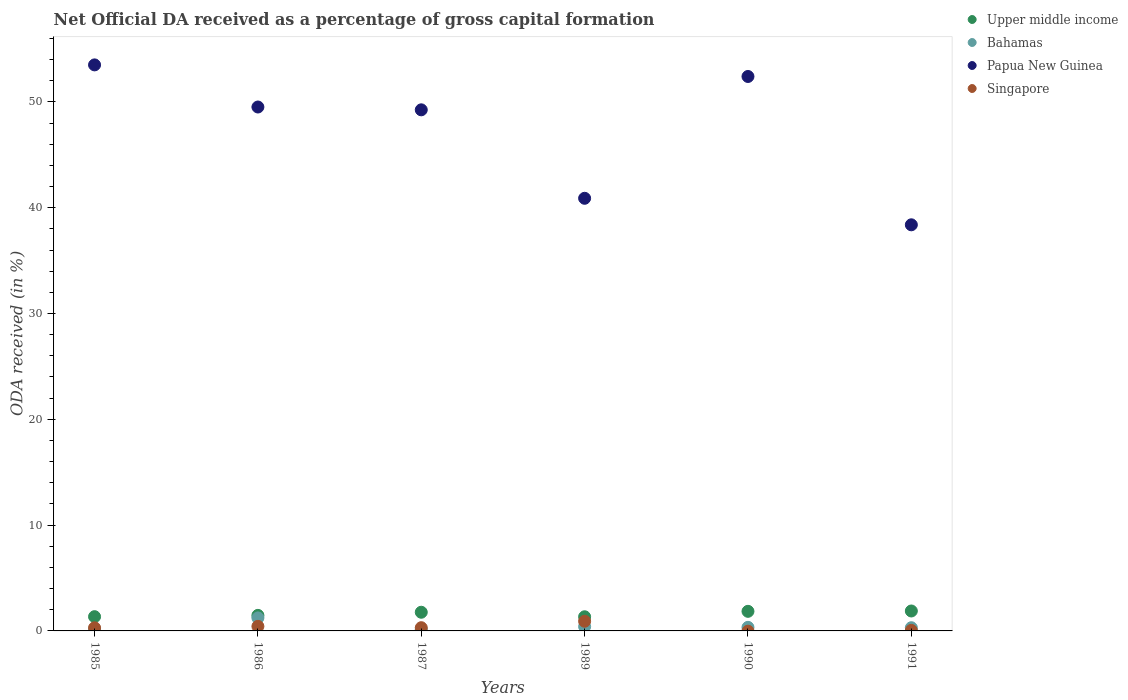Is the number of dotlines equal to the number of legend labels?
Provide a short and direct response. No. What is the net ODA received in Papua New Guinea in 1989?
Ensure brevity in your answer.  40.89. Across all years, what is the maximum net ODA received in Upper middle income?
Provide a short and direct response. 1.88. Across all years, what is the minimum net ODA received in Bahamas?
Your answer should be very brief. 0.13. What is the total net ODA received in Bahamas in the graph?
Offer a very short reply. 2.56. What is the difference between the net ODA received in Bahamas in 1985 and that in 1991?
Offer a terse response. -0.14. What is the difference between the net ODA received in Bahamas in 1989 and the net ODA received in Upper middle income in 1986?
Your answer should be compact. -1.06. What is the average net ODA received in Papua New Guinea per year?
Provide a short and direct response. 47.32. In the year 1991, what is the difference between the net ODA received in Singapore and net ODA received in Bahamas?
Keep it short and to the point. -0.25. In how many years, is the net ODA received in Papua New Guinea greater than 32 %?
Your answer should be compact. 6. What is the ratio of the net ODA received in Singapore in 1986 to that in 1989?
Give a very brief answer. 0.47. Is the net ODA received in Upper middle income in 1989 less than that in 1991?
Your answer should be compact. Yes. Is the difference between the net ODA received in Singapore in 1986 and 1987 greater than the difference between the net ODA received in Bahamas in 1986 and 1987?
Your answer should be very brief. No. What is the difference between the highest and the second highest net ODA received in Papua New Guinea?
Keep it short and to the point. 1.1. What is the difference between the highest and the lowest net ODA received in Singapore?
Provide a short and direct response. 0.91. Is it the case that in every year, the sum of the net ODA received in Bahamas and net ODA received in Singapore  is greater than the net ODA received in Upper middle income?
Make the answer very short. No. How many years are there in the graph?
Offer a very short reply. 6. Are the values on the major ticks of Y-axis written in scientific E-notation?
Provide a short and direct response. No. How are the legend labels stacked?
Your response must be concise. Vertical. What is the title of the graph?
Your answer should be compact. Net Official DA received as a percentage of gross capital formation. Does "Lesotho" appear as one of the legend labels in the graph?
Offer a terse response. No. What is the label or title of the Y-axis?
Keep it short and to the point. ODA received (in %). What is the ODA received (in %) in Upper middle income in 1985?
Give a very brief answer. 1.35. What is the ODA received (in %) in Bahamas in 1985?
Ensure brevity in your answer.  0.16. What is the ODA received (in %) of Papua New Guinea in 1985?
Make the answer very short. 53.5. What is the ODA received (in %) in Singapore in 1985?
Provide a succinct answer. 0.3. What is the ODA received (in %) of Upper middle income in 1986?
Provide a short and direct response. 1.47. What is the ODA received (in %) in Bahamas in 1986?
Make the answer very short. 1.23. What is the ODA received (in %) of Papua New Guinea in 1986?
Offer a terse response. 49.52. What is the ODA received (in %) of Singapore in 1986?
Provide a short and direct response. 0.43. What is the ODA received (in %) of Upper middle income in 1987?
Your answer should be compact. 1.76. What is the ODA received (in %) of Bahamas in 1987?
Keep it short and to the point. 0.13. What is the ODA received (in %) of Papua New Guinea in 1987?
Provide a succinct answer. 49.25. What is the ODA received (in %) in Singapore in 1987?
Keep it short and to the point. 0.3. What is the ODA received (in %) in Upper middle income in 1989?
Provide a succinct answer. 1.34. What is the ODA received (in %) in Bahamas in 1989?
Your answer should be compact. 0.41. What is the ODA received (in %) of Papua New Guinea in 1989?
Your answer should be very brief. 40.89. What is the ODA received (in %) of Singapore in 1989?
Your response must be concise. 0.91. What is the ODA received (in %) of Upper middle income in 1990?
Your response must be concise. 1.85. What is the ODA received (in %) of Bahamas in 1990?
Offer a terse response. 0.34. What is the ODA received (in %) of Papua New Guinea in 1990?
Your answer should be compact. 52.4. What is the ODA received (in %) in Upper middle income in 1991?
Offer a terse response. 1.88. What is the ODA received (in %) in Bahamas in 1991?
Your answer should be very brief. 0.3. What is the ODA received (in %) of Papua New Guinea in 1991?
Offer a very short reply. 38.38. What is the ODA received (in %) in Singapore in 1991?
Offer a very short reply. 0.05. Across all years, what is the maximum ODA received (in %) of Upper middle income?
Provide a succinct answer. 1.88. Across all years, what is the maximum ODA received (in %) in Bahamas?
Offer a terse response. 1.23. Across all years, what is the maximum ODA received (in %) of Papua New Guinea?
Make the answer very short. 53.5. Across all years, what is the maximum ODA received (in %) of Singapore?
Provide a succinct answer. 0.91. Across all years, what is the minimum ODA received (in %) of Upper middle income?
Ensure brevity in your answer.  1.34. Across all years, what is the minimum ODA received (in %) in Bahamas?
Offer a very short reply. 0.13. Across all years, what is the minimum ODA received (in %) of Papua New Guinea?
Provide a short and direct response. 38.38. What is the total ODA received (in %) of Upper middle income in the graph?
Your answer should be very brief. 9.65. What is the total ODA received (in %) of Bahamas in the graph?
Make the answer very short. 2.56. What is the total ODA received (in %) in Papua New Guinea in the graph?
Ensure brevity in your answer.  283.94. What is the total ODA received (in %) of Singapore in the graph?
Your answer should be very brief. 2. What is the difference between the ODA received (in %) in Upper middle income in 1985 and that in 1986?
Offer a very short reply. -0.12. What is the difference between the ODA received (in %) in Bahamas in 1985 and that in 1986?
Provide a succinct answer. -1.07. What is the difference between the ODA received (in %) of Papua New Guinea in 1985 and that in 1986?
Give a very brief answer. 3.98. What is the difference between the ODA received (in %) of Singapore in 1985 and that in 1986?
Provide a succinct answer. -0.14. What is the difference between the ODA received (in %) of Upper middle income in 1985 and that in 1987?
Your answer should be compact. -0.42. What is the difference between the ODA received (in %) in Bahamas in 1985 and that in 1987?
Offer a terse response. 0.03. What is the difference between the ODA received (in %) in Papua New Guinea in 1985 and that in 1987?
Give a very brief answer. 4.25. What is the difference between the ODA received (in %) of Singapore in 1985 and that in 1987?
Your answer should be compact. -0.01. What is the difference between the ODA received (in %) of Upper middle income in 1985 and that in 1989?
Provide a succinct answer. 0.01. What is the difference between the ODA received (in %) of Bahamas in 1985 and that in 1989?
Your response must be concise. -0.25. What is the difference between the ODA received (in %) in Papua New Guinea in 1985 and that in 1989?
Provide a short and direct response. 12.61. What is the difference between the ODA received (in %) in Singapore in 1985 and that in 1989?
Your answer should be very brief. -0.62. What is the difference between the ODA received (in %) of Upper middle income in 1985 and that in 1990?
Your response must be concise. -0.5. What is the difference between the ODA received (in %) of Bahamas in 1985 and that in 1990?
Make the answer very short. -0.18. What is the difference between the ODA received (in %) in Papua New Guinea in 1985 and that in 1990?
Your answer should be very brief. 1.1. What is the difference between the ODA received (in %) in Upper middle income in 1985 and that in 1991?
Give a very brief answer. -0.54. What is the difference between the ODA received (in %) in Bahamas in 1985 and that in 1991?
Keep it short and to the point. -0.14. What is the difference between the ODA received (in %) of Papua New Guinea in 1985 and that in 1991?
Your answer should be very brief. 15.11. What is the difference between the ODA received (in %) in Singapore in 1985 and that in 1991?
Your answer should be compact. 0.24. What is the difference between the ODA received (in %) in Upper middle income in 1986 and that in 1987?
Make the answer very short. -0.3. What is the difference between the ODA received (in %) in Bahamas in 1986 and that in 1987?
Make the answer very short. 1.1. What is the difference between the ODA received (in %) in Papua New Guinea in 1986 and that in 1987?
Make the answer very short. 0.27. What is the difference between the ODA received (in %) in Singapore in 1986 and that in 1987?
Provide a short and direct response. 0.13. What is the difference between the ODA received (in %) in Upper middle income in 1986 and that in 1989?
Offer a very short reply. 0.13. What is the difference between the ODA received (in %) in Bahamas in 1986 and that in 1989?
Make the answer very short. 0.82. What is the difference between the ODA received (in %) of Papua New Guinea in 1986 and that in 1989?
Keep it short and to the point. 8.63. What is the difference between the ODA received (in %) in Singapore in 1986 and that in 1989?
Keep it short and to the point. -0.48. What is the difference between the ODA received (in %) of Upper middle income in 1986 and that in 1990?
Offer a very short reply. -0.38. What is the difference between the ODA received (in %) of Bahamas in 1986 and that in 1990?
Offer a very short reply. 0.89. What is the difference between the ODA received (in %) in Papua New Guinea in 1986 and that in 1990?
Give a very brief answer. -2.89. What is the difference between the ODA received (in %) of Upper middle income in 1986 and that in 1991?
Offer a very short reply. -0.41. What is the difference between the ODA received (in %) of Bahamas in 1986 and that in 1991?
Provide a short and direct response. 0.93. What is the difference between the ODA received (in %) of Papua New Guinea in 1986 and that in 1991?
Offer a terse response. 11.13. What is the difference between the ODA received (in %) of Singapore in 1986 and that in 1991?
Your answer should be compact. 0.38. What is the difference between the ODA received (in %) of Upper middle income in 1987 and that in 1989?
Offer a terse response. 0.43. What is the difference between the ODA received (in %) in Bahamas in 1987 and that in 1989?
Offer a terse response. -0.28. What is the difference between the ODA received (in %) of Papua New Guinea in 1987 and that in 1989?
Give a very brief answer. 8.36. What is the difference between the ODA received (in %) of Singapore in 1987 and that in 1989?
Ensure brevity in your answer.  -0.61. What is the difference between the ODA received (in %) of Upper middle income in 1987 and that in 1990?
Give a very brief answer. -0.09. What is the difference between the ODA received (in %) in Bahamas in 1987 and that in 1990?
Make the answer very short. -0.21. What is the difference between the ODA received (in %) of Papua New Guinea in 1987 and that in 1990?
Offer a very short reply. -3.15. What is the difference between the ODA received (in %) of Upper middle income in 1987 and that in 1991?
Your response must be concise. -0.12. What is the difference between the ODA received (in %) in Bahamas in 1987 and that in 1991?
Offer a terse response. -0.17. What is the difference between the ODA received (in %) in Papua New Guinea in 1987 and that in 1991?
Your response must be concise. 10.87. What is the difference between the ODA received (in %) of Singapore in 1987 and that in 1991?
Your answer should be very brief. 0.25. What is the difference between the ODA received (in %) in Upper middle income in 1989 and that in 1990?
Offer a very short reply. -0.51. What is the difference between the ODA received (in %) in Bahamas in 1989 and that in 1990?
Make the answer very short. 0.07. What is the difference between the ODA received (in %) of Papua New Guinea in 1989 and that in 1990?
Provide a succinct answer. -11.51. What is the difference between the ODA received (in %) in Upper middle income in 1989 and that in 1991?
Provide a short and direct response. -0.55. What is the difference between the ODA received (in %) of Bahamas in 1989 and that in 1991?
Give a very brief answer. 0.1. What is the difference between the ODA received (in %) in Papua New Guinea in 1989 and that in 1991?
Keep it short and to the point. 2.51. What is the difference between the ODA received (in %) of Singapore in 1989 and that in 1991?
Keep it short and to the point. 0.86. What is the difference between the ODA received (in %) in Upper middle income in 1990 and that in 1991?
Offer a very short reply. -0.03. What is the difference between the ODA received (in %) of Bahamas in 1990 and that in 1991?
Ensure brevity in your answer.  0.04. What is the difference between the ODA received (in %) of Papua New Guinea in 1990 and that in 1991?
Give a very brief answer. 14.02. What is the difference between the ODA received (in %) of Upper middle income in 1985 and the ODA received (in %) of Bahamas in 1986?
Provide a succinct answer. 0.12. What is the difference between the ODA received (in %) of Upper middle income in 1985 and the ODA received (in %) of Papua New Guinea in 1986?
Keep it short and to the point. -48.17. What is the difference between the ODA received (in %) of Upper middle income in 1985 and the ODA received (in %) of Singapore in 1986?
Ensure brevity in your answer.  0.92. What is the difference between the ODA received (in %) of Bahamas in 1985 and the ODA received (in %) of Papua New Guinea in 1986?
Your answer should be compact. -49.36. What is the difference between the ODA received (in %) in Bahamas in 1985 and the ODA received (in %) in Singapore in 1986?
Offer a terse response. -0.27. What is the difference between the ODA received (in %) of Papua New Guinea in 1985 and the ODA received (in %) of Singapore in 1986?
Provide a short and direct response. 53.07. What is the difference between the ODA received (in %) of Upper middle income in 1985 and the ODA received (in %) of Bahamas in 1987?
Ensure brevity in your answer.  1.22. What is the difference between the ODA received (in %) in Upper middle income in 1985 and the ODA received (in %) in Papua New Guinea in 1987?
Your answer should be very brief. -47.9. What is the difference between the ODA received (in %) in Upper middle income in 1985 and the ODA received (in %) in Singapore in 1987?
Ensure brevity in your answer.  1.04. What is the difference between the ODA received (in %) of Bahamas in 1985 and the ODA received (in %) of Papua New Guinea in 1987?
Provide a short and direct response. -49.09. What is the difference between the ODA received (in %) of Bahamas in 1985 and the ODA received (in %) of Singapore in 1987?
Make the answer very short. -0.15. What is the difference between the ODA received (in %) in Papua New Guinea in 1985 and the ODA received (in %) in Singapore in 1987?
Give a very brief answer. 53.19. What is the difference between the ODA received (in %) in Upper middle income in 1985 and the ODA received (in %) in Bahamas in 1989?
Your response must be concise. 0.94. What is the difference between the ODA received (in %) of Upper middle income in 1985 and the ODA received (in %) of Papua New Guinea in 1989?
Make the answer very short. -39.54. What is the difference between the ODA received (in %) in Upper middle income in 1985 and the ODA received (in %) in Singapore in 1989?
Your response must be concise. 0.43. What is the difference between the ODA received (in %) of Bahamas in 1985 and the ODA received (in %) of Papua New Guinea in 1989?
Provide a short and direct response. -40.73. What is the difference between the ODA received (in %) in Bahamas in 1985 and the ODA received (in %) in Singapore in 1989?
Provide a succinct answer. -0.76. What is the difference between the ODA received (in %) of Papua New Guinea in 1985 and the ODA received (in %) of Singapore in 1989?
Make the answer very short. 52.58. What is the difference between the ODA received (in %) of Upper middle income in 1985 and the ODA received (in %) of Bahamas in 1990?
Make the answer very short. 1.01. What is the difference between the ODA received (in %) in Upper middle income in 1985 and the ODA received (in %) in Papua New Guinea in 1990?
Offer a terse response. -51.06. What is the difference between the ODA received (in %) in Bahamas in 1985 and the ODA received (in %) in Papua New Guinea in 1990?
Make the answer very short. -52.25. What is the difference between the ODA received (in %) of Upper middle income in 1985 and the ODA received (in %) of Bahamas in 1991?
Your response must be concise. 1.04. What is the difference between the ODA received (in %) of Upper middle income in 1985 and the ODA received (in %) of Papua New Guinea in 1991?
Ensure brevity in your answer.  -37.04. What is the difference between the ODA received (in %) in Upper middle income in 1985 and the ODA received (in %) in Singapore in 1991?
Your response must be concise. 1.3. What is the difference between the ODA received (in %) in Bahamas in 1985 and the ODA received (in %) in Papua New Guinea in 1991?
Provide a short and direct response. -38.23. What is the difference between the ODA received (in %) of Bahamas in 1985 and the ODA received (in %) of Singapore in 1991?
Offer a very short reply. 0.11. What is the difference between the ODA received (in %) of Papua New Guinea in 1985 and the ODA received (in %) of Singapore in 1991?
Your answer should be compact. 53.45. What is the difference between the ODA received (in %) of Upper middle income in 1986 and the ODA received (in %) of Bahamas in 1987?
Give a very brief answer. 1.34. What is the difference between the ODA received (in %) in Upper middle income in 1986 and the ODA received (in %) in Papua New Guinea in 1987?
Your answer should be very brief. -47.78. What is the difference between the ODA received (in %) in Upper middle income in 1986 and the ODA received (in %) in Singapore in 1987?
Your answer should be very brief. 1.16. What is the difference between the ODA received (in %) of Bahamas in 1986 and the ODA received (in %) of Papua New Guinea in 1987?
Your answer should be very brief. -48.02. What is the difference between the ODA received (in %) of Bahamas in 1986 and the ODA received (in %) of Singapore in 1987?
Make the answer very short. 0.92. What is the difference between the ODA received (in %) in Papua New Guinea in 1986 and the ODA received (in %) in Singapore in 1987?
Provide a short and direct response. 49.21. What is the difference between the ODA received (in %) in Upper middle income in 1986 and the ODA received (in %) in Bahamas in 1989?
Make the answer very short. 1.06. What is the difference between the ODA received (in %) in Upper middle income in 1986 and the ODA received (in %) in Papua New Guinea in 1989?
Your answer should be compact. -39.42. What is the difference between the ODA received (in %) in Upper middle income in 1986 and the ODA received (in %) in Singapore in 1989?
Offer a very short reply. 0.56. What is the difference between the ODA received (in %) of Bahamas in 1986 and the ODA received (in %) of Papua New Guinea in 1989?
Offer a very short reply. -39.66. What is the difference between the ODA received (in %) in Bahamas in 1986 and the ODA received (in %) in Singapore in 1989?
Provide a short and direct response. 0.32. What is the difference between the ODA received (in %) in Papua New Guinea in 1986 and the ODA received (in %) in Singapore in 1989?
Your response must be concise. 48.6. What is the difference between the ODA received (in %) in Upper middle income in 1986 and the ODA received (in %) in Bahamas in 1990?
Your response must be concise. 1.13. What is the difference between the ODA received (in %) of Upper middle income in 1986 and the ODA received (in %) of Papua New Guinea in 1990?
Ensure brevity in your answer.  -50.93. What is the difference between the ODA received (in %) of Bahamas in 1986 and the ODA received (in %) of Papua New Guinea in 1990?
Your answer should be very brief. -51.17. What is the difference between the ODA received (in %) in Upper middle income in 1986 and the ODA received (in %) in Bahamas in 1991?
Provide a succinct answer. 1.17. What is the difference between the ODA received (in %) in Upper middle income in 1986 and the ODA received (in %) in Papua New Guinea in 1991?
Your answer should be compact. -36.91. What is the difference between the ODA received (in %) of Upper middle income in 1986 and the ODA received (in %) of Singapore in 1991?
Provide a succinct answer. 1.42. What is the difference between the ODA received (in %) in Bahamas in 1986 and the ODA received (in %) in Papua New Guinea in 1991?
Offer a very short reply. -37.15. What is the difference between the ODA received (in %) of Bahamas in 1986 and the ODA received (in %) of Singapore in 1991?
Give a very brief answer. 1.18. What is the difference between the ODA received (in %) of Papua New Guinea in 1986 and the ODA received (in %) of Singapore in 1991?
Provide a short and direct response. 49.47. What is the difference between the ODA received (in %) in Upper middle income in 1987 and the ODA received (in %) in Bahamas in 1989?
Your response must be concise. 1.36. What is the difference between the ODA received (in %) in Upper middle income in 1987 and the ODA received (in %) in Papua New Guinea in 1989?
Offer a terse response. -39.13. What is the difference between the ODA received (in %) in Upper middle income in 1987 and the ODA received (in %) in Singapore in 1989?
Your response must be concise. 0.85. What is the difference between the ODA received (in %) in Bahamas in 1987 and the ODA received (in %) in Papua New Guinea in 1989?
Keep it short and to the point. -40.76. What is the difference between the ODA received (in %) of Bahamas in 1987 and the ODA received (in %) of Singapore in 1989?
Your answer should be compact. -0.78. What is the difference between the ODA received (in %) of Papua New Guinea in 1987 and the ODA received (in %) of Singapore in 1989?
Ensure brevity in your answer.  48.34. What is the difference between the ODA received (in %) of Upper middle income in 1987 and the ODA received (in %) of Bahamas in 1990?
Provide a succinct answer. 1.43. What is the difference between the ODA received (in %) in Upper middle income in 1987 and the ODA received (in %) in Papua New Guinea in 1990?
Your answer should be compact. -50.64. What is the difference between the ODA received (in %) in Bahamas in 1987 and the ODA received (in %) in Papua New Guinea in 1990?
Your response must be concise. -52.27. What is the difference between the ODA received (in %) of Upper middle income in 1987 and the ODA received (in %) of Bahamas in 1991?
Offer a very short reply. 1.46. What is the difference between the ODA received (in %) in Upper middle income in 1987 and the ODA received (in %) in Papua New Guinea in 1991?
Ensure brevity in your answer.  -36.62. What is the difference between the ODA received (in %) in Upper middle income in 1987 and the ODA received (in %) in Singapore in 1991?
Offer a terse response. 1.71. What is the difference between the ODA received (in %) in Bahamas in 1987 and the ODA received (in %) in Papua New Guinea in 1991?
Your answer should be very brief. -38.25. What is the difference between the ODA received (in %) of Bahamas in 1987 and the ODA received (in %) of Singapore in 1991?
Keep it short and to the point. 0.08. What is the difference between the ODA received (in %) in Papua New Guinea in 1987 and the ODA received (in %) in Singapore in 1991?
Give a very brief answer. 49.2. What is the difference between the ODA received (in %) in Upper middle income in 1989 and the ODA received (in %) in Bahamas in 1990?
Give a very brief answer. 1. What is the difference between the ODA received (in %) in Upper middle income in 1989 and the ODA received (in %) in Papua New Guinea in 1990?
Make the answer very short. -51.06. What is the difference between the ODA received (in %) of Bahamas in 1989 and the ODA received (in %) of Papua New Guinea in 1990?
Your answer should be compact. -52. What is the difference between the ODA received (in %) in Upper middle income in 1989 and the ODA received (in %) in Bahamas in 1991?
Offer a terse response. 1.04. What is the difference between the ODA received (in %) in Upper middle income in 1989 and the ODA received (in %) in Papua New Guinea in 1991?
Ensure brevity in your answer.  -37.05. What is the difference between the ODA received (in %) in Upper middle income in 1989 and the ODA received (in %) in Singapore in 1991?
Your response must be concise. 1.29. What is the difference between the ODA received (in %) in Bahamas in 1989 and the ODA received (in %) in Papua New Guinea in 1991?
Give a very brief answer. -37.98. What is the difference between the ODA received (in %) in Bahamas in 1989 and the ODA received (in %) in Singapore in 1991?
Make the answer very short. 0.36. What is the difference between the ODA received (in %) in Papua New Guinea in 1989 and the ODA received (in %) in Singapore in 1991?
Your answer should be compact. 40.84. What is the difference between the ODA received (in %) of Upper middle income in 1990 and the ODA received (in %) of Bahamas in 1991?
Provide a short and direct response. 1.55. What is the difference between the ODA received (in %) in Upper middle income in 1990 and the ODA received (in %) in Papua New Guinea in 1991?
Provide a succinct answer. -36.53. What is the difference between the ODA received (in %) of Upper middle income in 1990 and the ODA received (in %) of Singapore in 1991?
Offer a terse response. 1.8. What is the difference between the ODA received (in %) of Bahamas in 1990 and the ODA received (in %) of Papua New Guinea in 1991?
Ensure brevity in your answer.  -38.05. What is the difference between the ODA received (in %) in Bahamas in 1990 and the ODA received (in %) in Singapore in 1991?
Your response must be concise. 0.29. What is the difference between the ODA received (in %) of Papua New Guinea in 1990 and the ODA received (in %) of Singapore in 1991?
Give a very brief answer. 52.35. What is the average ODA received (in %) of Upper middle income per year?
Provide a succinct answer. 1.61. What is the average ODA received (in %) of Bahamas per year?
Offer a very short reply. 0.43. What is the average ODA received (in %) of Papua New Guinea per year?
Provide a short and direct response. 47.32. What is the average ODA received (in %) in Singapore per year?
Give a very brief answer. 0.33. In the year 1985, what is the difference between the ODA received (in %) in Upper middle income and ODA received (in %) in Bahamas?
Keep it short and to the point. 1.19. In the year 1985, what is the difference between the ODA received (in %) in Upper middle income and ODA received (in %) in Papua New Guinea?
Make the answer very short. -52.15. In the year 1985, what is the difference between the ODA received (in %) of Upper middle income and ODA received (in %) of Singapore?
Provide a short and direct response. 1.05. In the year 1985, what is the difference between the ODA received (in %) of Bahamas and ODA received (in %) of Papua New Guinea?
Offer a very short reply. -53.34. In the year 1985, what is the difference between the ODA received (in %) in Bahamas and ODA received (in %) in Singapore?
Offer a very short reply. -0.14. In the year 1985, what is the difference between the ODA received (in %) of Papua New Guinea and ODA received (in %) of Singapore?
Offer a very short reply. 53.2. In the year 1986, what is the difference between the ODA received (in %) of Upper middle income and ODA received (in %) of Bahamas?
Provide a short and direct response. 0.24. In the year 1986, what is the difference between the ODA received (in %) of Upper middle income and ODA received (in %) of Papua New Guinea?
Make the answer very short. -48.05. In the year 1986, what is the difference between the ODA received (in %) in Upper middle income and ODA received (in %) in Singapore?
Offer a terse response. 1.04. In the year 1986, what is the difference between the ODA received (in %) in Bahamas and ODA received (in %) in Papua New Guinea?
Your answer should be compact. -48.29. In the year 1986, what is the difference between the ODA received (in %) in Bahamas and ODA received (in %) in Singapore?
Your answer should be very brief. 0.8. In the year 1986, what is the difference between the ODA received (in %) of Papua New Guinea and ODA received (in %) of Singapore?
Your response must be concise. 49.09. In the year 1987, what is the difference between the ODA received (in %) of Upper middle income and ODA received (in %) of Bahamas?
Give a very brief answer. 1.63. In the year 1987, what is the difference between the ODA received (in %) in Upper middle income and ODA received (in %) in Papua New Guinea?
Your answer should be very brief. -47.49. In the year 1987, what is the difference between the ODA received (in %) in Upper middle income and ODA received (in %) in Singapore?
Your answer should be very brief. 1.46. In the year 1987, what is the difference between the ODA received (in %) of Bahamas and ODA received (in %) of Papua New Guinea?
Provide a short and direct response. -49.12. In the year 1987, what is the difference between the ODA received (in %) of Bahamas and ODA received (in %) of Singapore?
Your answer should be compact. -0.17. In the year 1987, what is the difference between the ODA received (in %) in Papua New Guinea and ODA received (in %) in Singapore?
Your answer should be very brief. 48.95. In the year 1989, what is the difference between the ODA received (in %) of Upper middle income and ODA received (in %) of Bahamas?
Your answer should be very brief. 0.93. In the year 1989, what is the difference between the ODA received (in %) of Upper middle income and ODA received (in %) of Papua New Guinea?
Your answer should be compact. -39.55. In the year 1989, what is the difference between the ODA received (in %) of Upper middle income and ODA received (in %) of Singapore?
Ensure brevity in your answer.  0.42. In the year 1989, what is the difference between the ODA received (in %) in Bahamas and ODA received (in %) in Papua New Guinea?
Offer a terse response. -40.48. In the year 1989, what is the difference between the ODA received (in %) of Bahamas and ODA received (in %) of Singapore?
Your answer should be very brief. -0.51. In the year 1989, what is the difference between the ODA received (in %) in Papua New Guinea and ODA received (in %) in Singapore?
Your answer should be compact. 39.98. In the year 1990, what is the difference between the ODA received (in %) of Upper middle income and ODA received (in %) of Bahamas?
Give a very brief answer. 1.51. In the year 1990, what is the difference between the ODA received (in %) in Upper middle income and ODA received (in %) in Papua New Guinea?
Offer a very short reply. -50.55. In the year 1990, what is the difference between the ODA received (in %) of Bahamas and ODA received (in %) of Papua New Guinea?
Offer a very short reply. -52.06. In the year 1991, what is the difference between the ODA received (in %) in Upper middle income and ODA received (in %) in Bahamas?
Give a very brief answer. 1.58. In the year 1991, what is the difference between the ODA received (in %) of Upper middle income and ODA received (in %) of Papua New Guinea?
Your response must be concise. -36.5. In the year 1991, what is the difference between the ODA received (in %) in Upper middle income and ODA received (in %) in Singapore?
Your response must be concise. 1.83. In the year 1991, what is the difference between the ODA received (in %) in Bahamas and ODA received (in %) in Papua New Guinea?
Offer a very short reply. -38.08. In the year 1991, what is the difference between the ODA received (in %) of Bahamas and ODA received (in %) of Singapore?
Provide a succinct answer. 0.25. In the year 1991, what is the difference between the ODA received (in %) of Papua New Guinea and ODA received (in %) of Singapore?
Provide a short and direct response. 38.33. What is the ratio of the ODA received (in %) in Upper middle income in 1985 to that in 1986?
Offer a terse response. 0.92. What is the ratio of the ODA received (in %) of Bahamas in 1985 to that in 1986?
Your response must be concise. 0.13. What is the ratio of the ODA received (in %) of Papua New Guinea in 1985 to that in 1986?
Your answer should be very brief. 1.08. What is the ratio of the ODA received (in %) in Singapore in 1985 to that in 1986?
Provide a short and direct response. 0.68. What is the ratio of the ODA received (in %) in Upper middle income in 1985 to that in 1987?
Your response must be concise. 0.76. What is the ratio of the ODA received (in %) in Bahamas in 1985 to that in 1987?
Ensure brevity in your answer.  1.2. What is the ratio of the ODA received (in %) of Papua New Guinea in 1985 to that in 1987?
Offer a very short reply. 1.09. What is the ratio of the ODA received (in %) of Singapore in 1985 to that in 1987?
Give a very brief answer. 0.97. What is the ratio of the ODA received (in %) in Bahamas in 1985 to that in 1989?
Your response must be concise. 0.39. What is the ratio of the ODA received (in %) of Papua New Guinea in 1985 to that in 1989?
Provide a short and direct response. 1.31. What is the ratio of the ODA received (in %) of Singapore in 1985 to that in 1989?
Your response must be concise. 0.32. What is the ratio of the ODA received (in %) of Upper middle income in 1985 to that in 1990?
Give a very brief answer. 0.73. What is the ratio of the ODA received (in %) in Bahamas in 1985 to that in 1990?
Ensure brevity in your answer.  0.47. What is the ratio of the ODA received (in %) of Papua New Guinea in 1985 to that in 1990?
Provide a succinct answer. 1.02. What is the ratio of the ODA received (in %) in Upper middle income in 1985 to that in 1991?
Your answer should be very brief. 0.71. What is the ratio of the ODA received (in %) of Bahamas in 1985 to that in 1991?
Your response must be concise. 0.52. What is the ratio of the ODA received (in %) in Papua New Guinea in 1985 to that in 1991?
Provide a short and direct response. 1.39. What is the ratio of the ODA received (in %) in Singapore in 1985 to that in 1991?
Keep it short and to the point. 5.87. What is the ratio of the ODA received (in %) in Upper middle income in 1986 to that in 1987?
Give a very brief answer. 0.83. What is the ratio of the ODA received (in %) of Bahamas in 1986 to that in 1987?
Your answer should be compact. 9.36. What is the ratio of the ODA received (in %) of Papua New Guinea in 1986 to that in 1987?
Keep it short and to the point. 1.01. What is the ratio of the ODA received (in %) of Singapore in 1986 to that in 1987?
Provide a short and direct response. 1.42. What is the ratio of the ODA received (in %) in Upper middle income in 1986 to that in 1989?
Make the answer very short. 1.1. What is the ratio of the ODA received (in %) in Bahamas in 1986 to that in 1989?
Your response must be concise. 3.02. What is the ratio of the ODA received (in %) of Papua New Guinea in 1986 to that in 1989?
Your answer should be compact. 1.21. What is the ratio of the ODA received (in %) of Singapore in 1986 to that in 1989?
Give a very brief answer. 0.47. What is the ratio of the ODA received (in %) in Upper middle income in 1986 to that in 1990?
Make the answer very short. 0.79. What is the ratio of the ODA received (in %) in Bahamas in 1986 to that in 1990?
Offer a terse response. 3.63. What is the ratio of the ODA received (in %) of Papua New Guinea in 1986 to that in 1990?
Offer a very short reply. 0.94. What is the ratio of the ODA received (in %) of Upper middle income in 1986 to that in 1991?
Offer a terse response. 0.78. What is the ratio of the ODA received (in %) of Bahamas in 1986 to that in 1991?
Your response must be concise. 4.07. What is the ratio of the ODA received (in %) in Papua New Guinea in 1986 to that in 1991?
Give a very brief answer. 1.29. What is the ratio of the ODA received (in %) of Singapore in 1986 to that in 1991?
Make the answer very short. 8.57. What is the ratio of the ODA received (in %) in Upper middle income in 1987 to that in 1989?
Make the answer very short. 1.32. What is the ratio of the ODA received (in %) of Bahamas in 1987 to that in 1989?
Your answer should be compact. 0.32. What is the ratio of the ODA received (in %) of Papua New Guinea in 1987 to that in 1989?
Keep it short and to the point. 1.2. What is the ratio of the ODA received (in %) of Singapore in 1987 to that in 1989?
Make the answer very short. 0.33. What is the ratio of the ODA received (in %) in Upper middle income in 1987 to that in 1990?
Make the answer very short. 0.95. What is the ratio of the ODA received (in %) in Bahamas in 1987 to that in 1990?
Make the answer very short. 0.39. What is the ratio of the ODA received (in %) of Papua New Guinea in 1987 to that in 1990?
Your answer should be very brief. 0.94. What is the ratio of the ODA received (in %) in Upper middle income in 1987 to that in 1991?
Keep it short and to the point. 0.94. What is the ratio of the ODA received (in %) of Bahamas in 1987 to that in 1991?
Keep it short and to the point. 0.43. What is the ratio of the ODA received (in %) of Papua New Guinea in 1987 to that in 1991?
Offer a very short reply. 1.28. What is the ratio of the ODA received (in %) of Singapore in 1987 to that in 1991?
Offer a terse response. 6.06. What is the ratio of the ODA received (in %) in Upper middle income in 1989 to that in 1990?
Give a very brief answer. 0.72. What is the ratio of the ODA received (in %) of Bahamas in 1989 to that in 1990?
Your response must be concise. 1.2. What is the ratio of the ODA received (in %) in Papua New Guinea in 1989 to that in 1990?
Your answer should be very brief. 0.78. What is the ratio of the ODA received (in %) of Upper middle income in 1989 to that in 1991?
Offer a terse response. 0.71. What is the ratio of the ODA received (in %) of Bahamas in 1989 to that in 1991?
Your response must be concise. 1.34. What is the ratio of the ODA received (in %) of Papua New Guinea in 1989 to that in 1991?
Your answer should be very brief. 1.07. What is the ratio of the ODA received (in %) in Singapore in 1989 to that in 1991?
Give a very brief answer. 18.17. What is the ratio of the ODA received (in %) of Upper middle income in 1990 to that in 1991?
Ensure brevity in your answer.  0.98. What is the ratio of the ODA received (in %) in Bahamas in 1990 to that in 1991?
Keep it short and to the point. 1.12. What is the ratio of the ODA received (in %) of Papua New Guinea in 1990 to that in 1991?
Offer a terse response. 1.37. What is the difference between the highest and the second highest ODA received (in %) in Upper middle income?
Provide a succinct answer. 0.03. What is the difference between the highest and the second highest ODA received (in %) in Bahamas?
Provide a succinct answer. 0.82. What is the difference between the highest and the second highest ODA received (in %) of Papua New Guinea?
Your response must be concise. 1.1. What is the difference between the highest and the second highest ODA received (in %) in Singapore?
Offer a terse response. 0.48. What is the difference between the highest and the lowest ODA received (in %) in Upper middle income?
Your response must be concise. 0.55. What is the difference between the highest and the lowest ODA received (in %) of Bahamas?
Provide a short and direct response. 1.1. What is the difference between the highest and the lowest ODA received (in %) of Papua New Guinea?
Offer a very short reply. 15.11. What is the difference between the highest and the lowest ODA received (in %) in Singapore?
Provide a succinct answer. 0.91. 